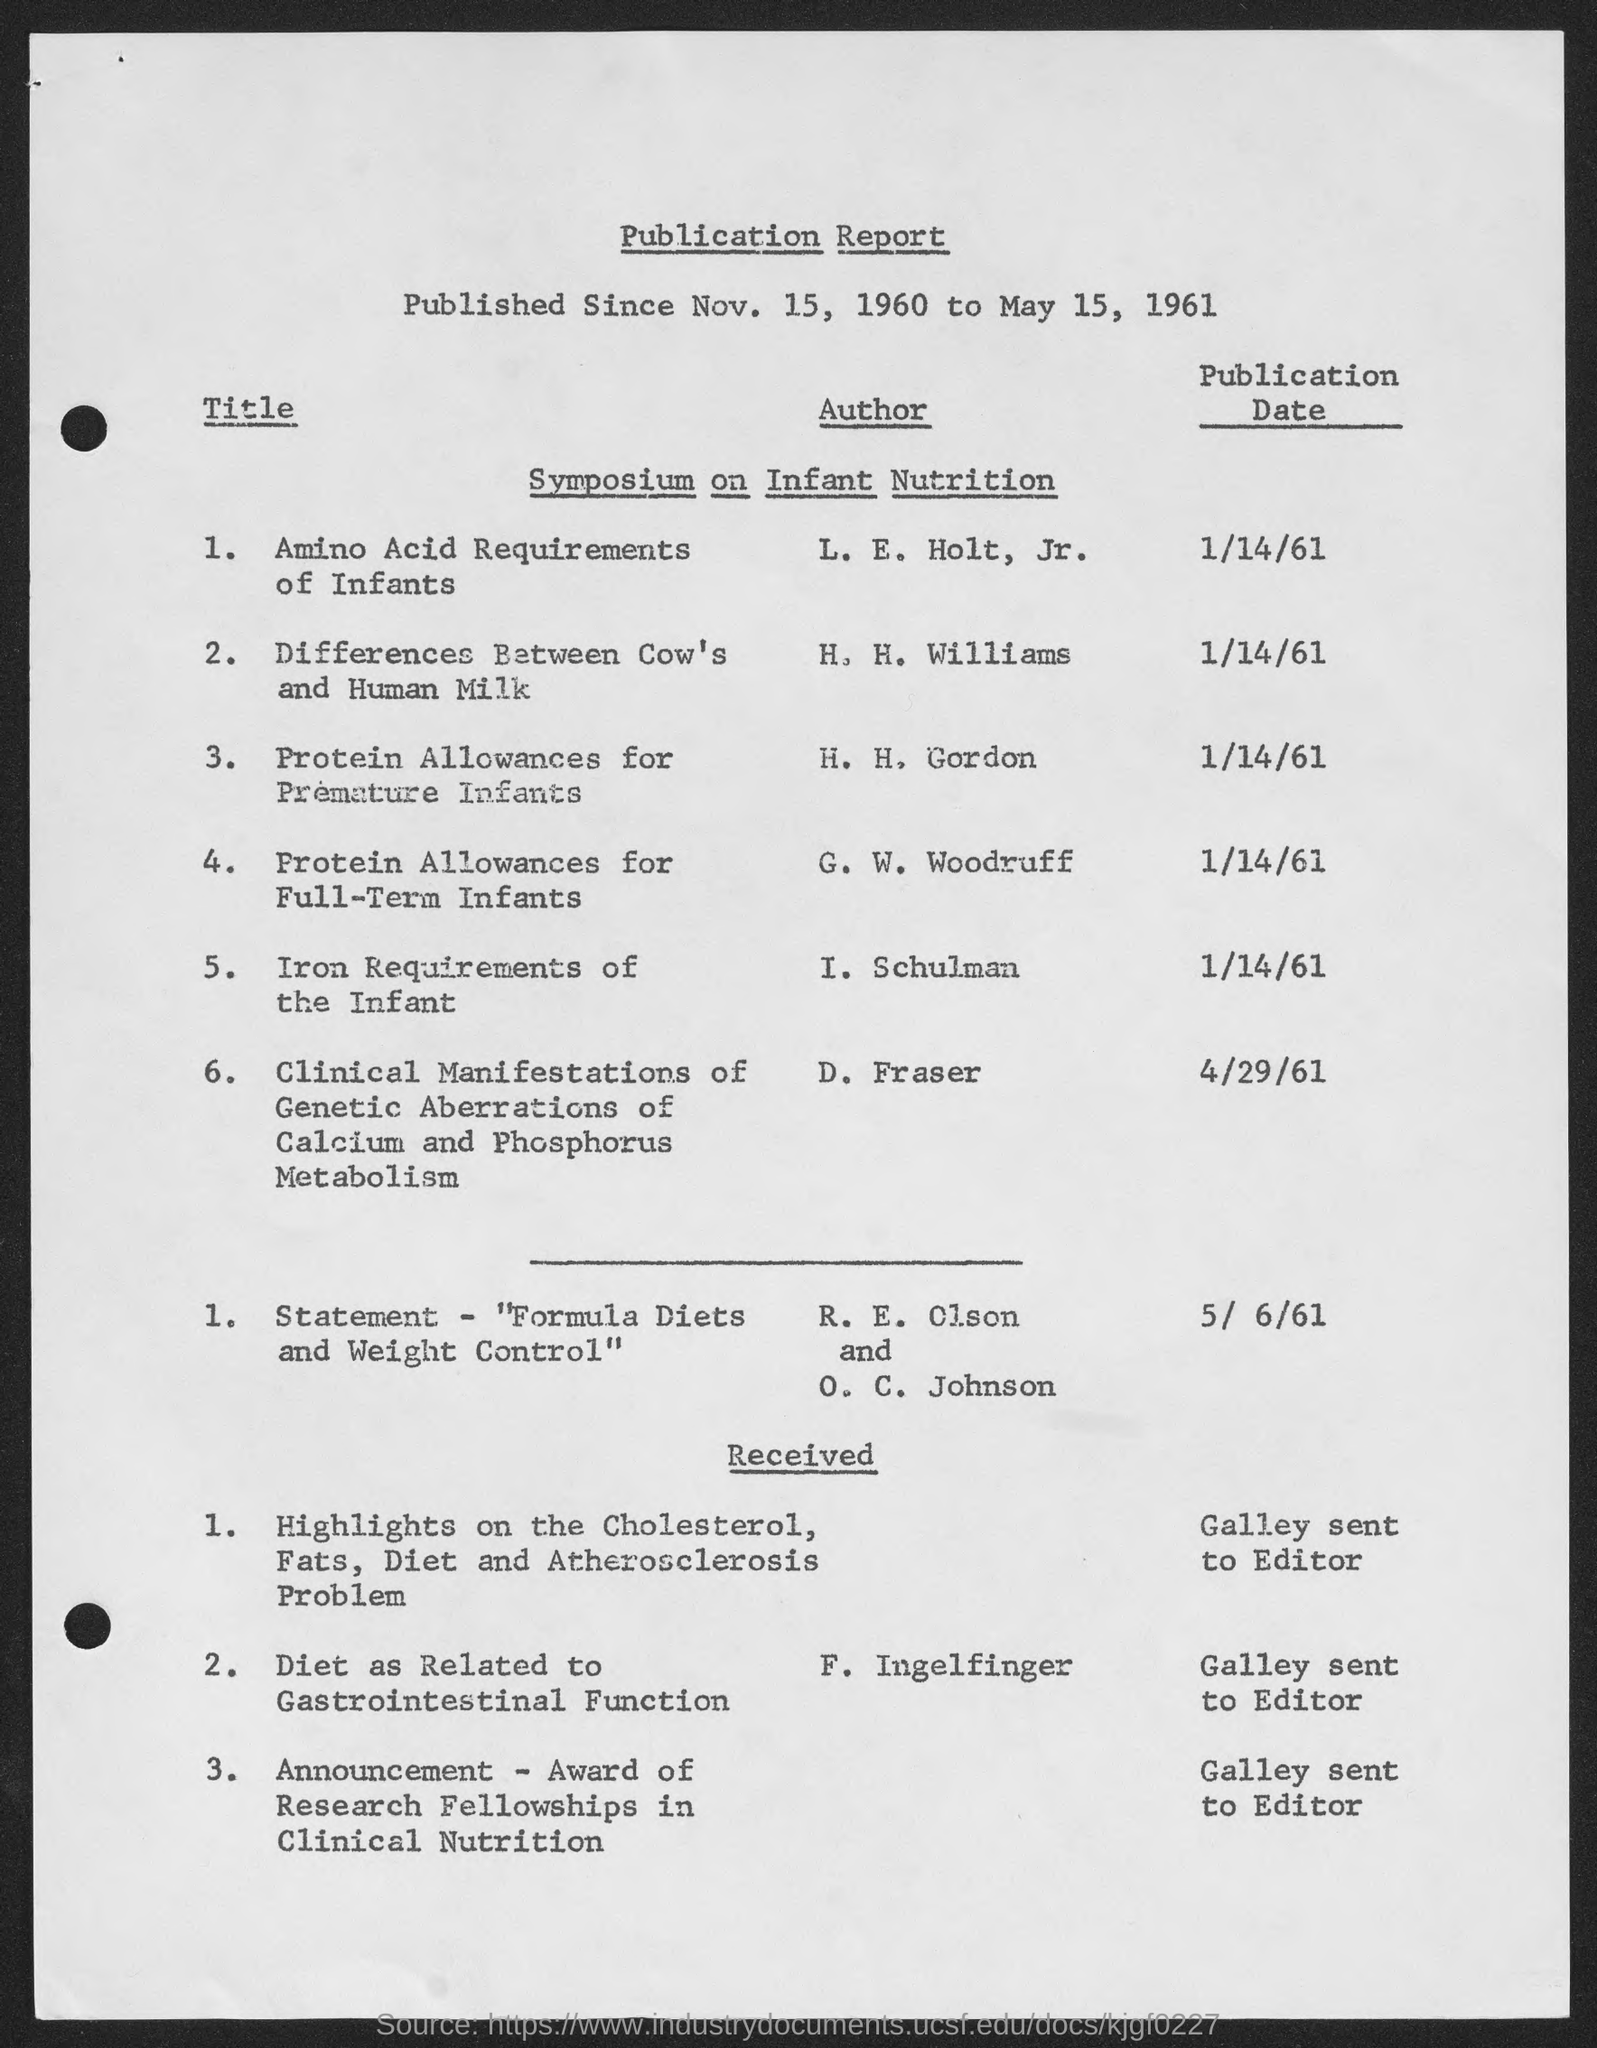What is the name of the report ?
Make the answer very short. Publication report. What is the publication date of amino acid requirements of infants ?
Make the answer very short. 1/14/61. What is the publication date of differences between cow's and human milk?
Provide a succinct answer. 1/14/61. What is the publication date of protein allowances for premature infants ?
Your response must be concise. 1/14/61. What is the publication date of protein allowances for full-term infants ?
Give a very brief answer. 1/14/61. What is the publication date of iron requirements of the infant ?
Your response must be concise. 1/14/61. What is the publication date of clinical manifestations of genetic aberrations of calcium and phosphorus metabolism?
Make the answer very short. 4/29/61. 